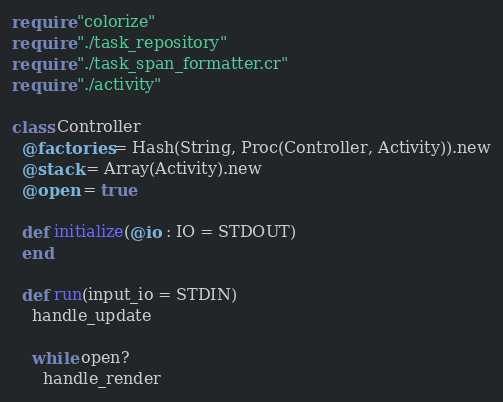Convert code to text. <code><loc_0><loc_0><loc_500><loc_500><_Crystal_>require "colorize"
require "./task_repository"
require "./task_span_formatter.cr"
require "./activity"

class Controller
  @factories = Hash(String, Proc(Controller, Activity)).new
  @stack = Array(Activity).new
  @open = true

  def initialize(@io : IO = STDOUT)
  end

  def run(input_io = STDIN)
    handle_update

    while open?
      handle_render
</code> 